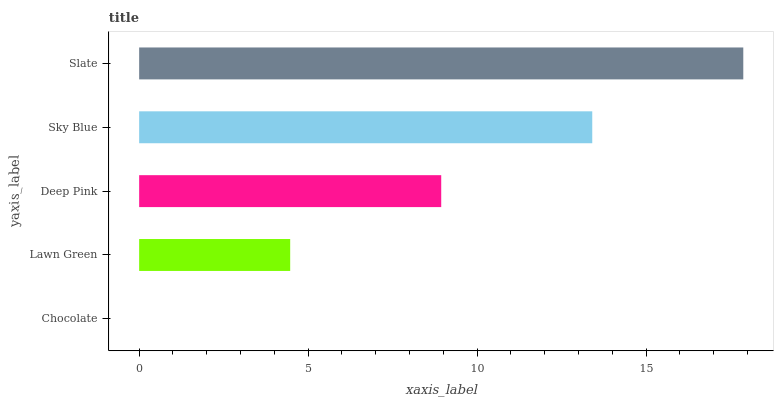Is Chocolate the minimum?
Answer yes or no. Yes. Is Slate the maximum?
Answer yes or no. Yes. Is Lawn Green the minimum?
Answer yes or no. No. Is Lawn Green the maximum?
Answer yes or no. No. Is Lawn Green greater than Chocolate?
Answer yes or no. Yes. Is Chocolate less than Lawn Green?
Answer yes or no. Yes. Is Chocolate greater than Lawn Green?
Answer yes or no. No. Is Lawn Green less than Chocolate?
Answer yes or no. No. Is Deep Pink the high median?
Answer yes or no. Yes. Is Deep Pink the low median?
Answer yes or no. Yes. Is Slate the high median?
Answer yes or no. No. Is Chocolate the low median?
Answer yes or no. No. 